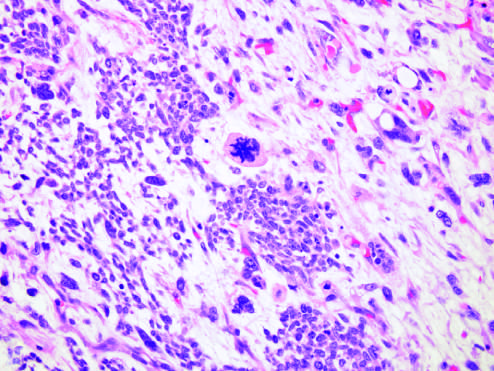what are associated with specific molecular lesions?
Answer the question using a single word or phrase. Predominance of blastemal morphology and diffuse anaplasia 